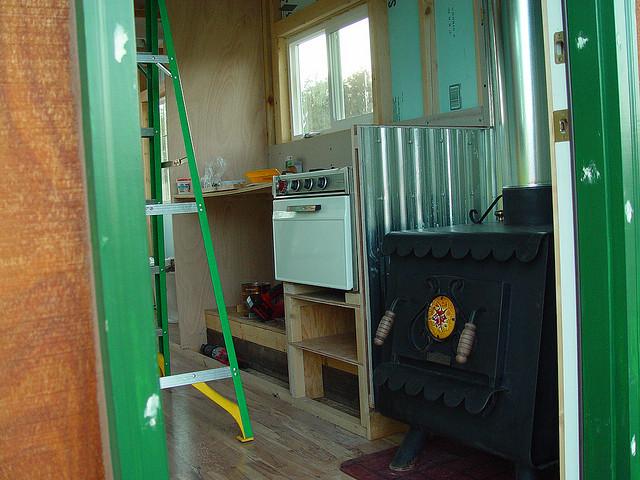Is this a contemporary kitchen?
Quick response, please. No. Is there a ladder to the left?
Keep it brief. Yes. What piece of equipment stands out the most?
Answer briefly. Stove. 